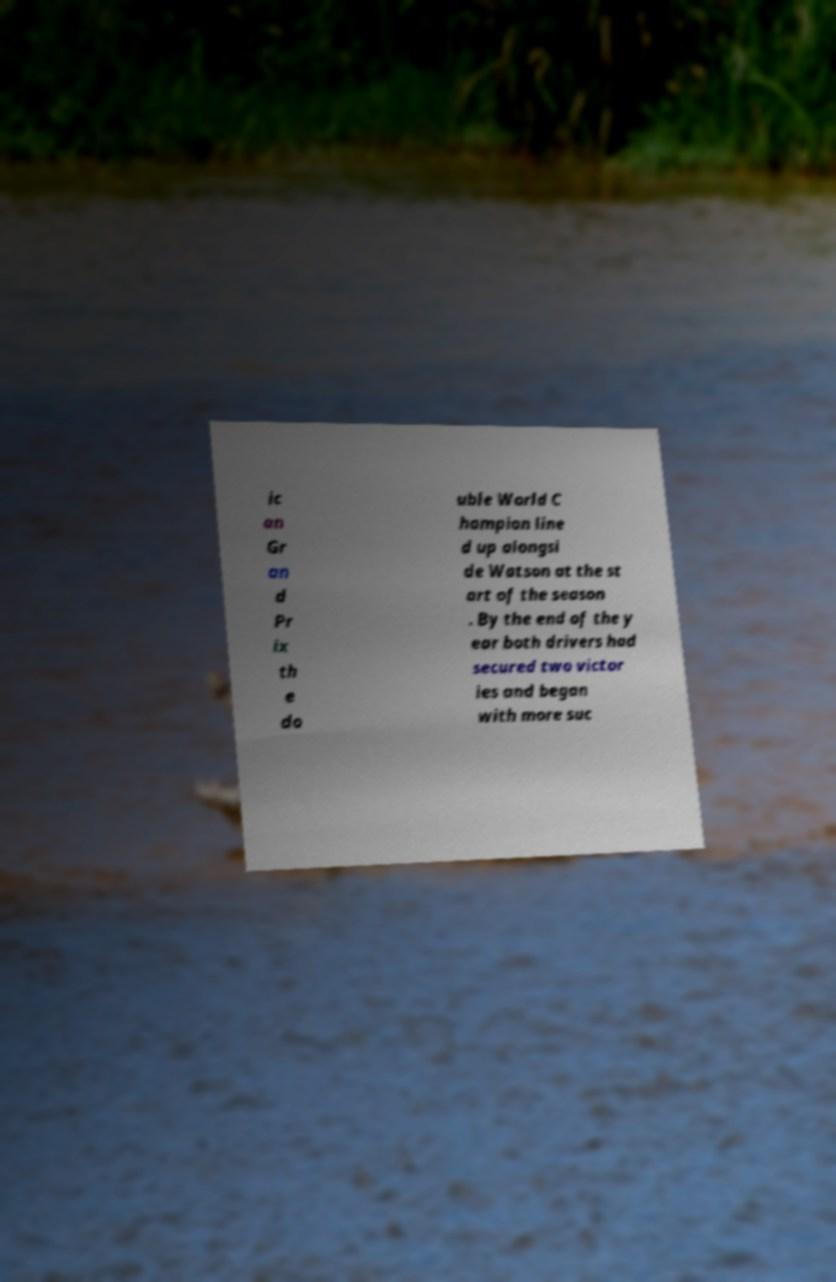I need the written content from this picture converted into text. Can you do that? ic an Gr an d Pr ix th e do uble World C hampion line d up alongsi de Watson at the st art of the season . By the end of the y ear both drivers had secured two victor ies and began with more suc 